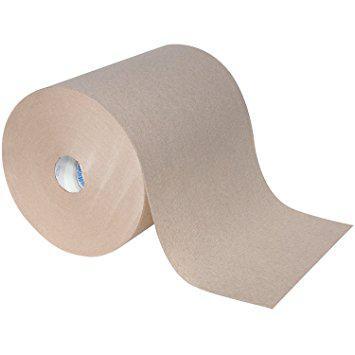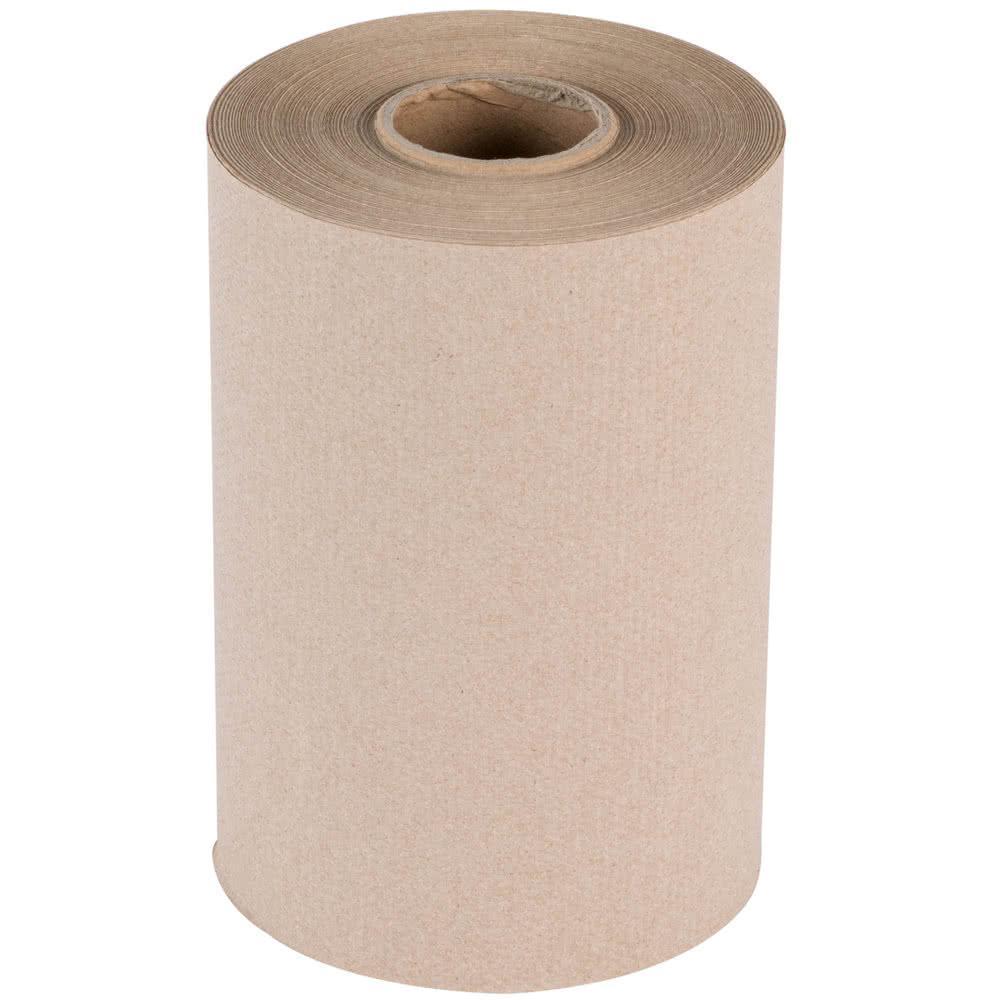The first image is the image on the left, the second image is the image on the right. Evaluate the accuracy of this statement regarding the images: "The roll of paper in the image on the left is partially unrolled". Is it true? Answer yes or no. Yes. The first image is the image on the left, the second image is the image on the right. Considering the images on both sides, is "No paper towel rolls have sheets unfurled." valid? Answer yes or no. No. 